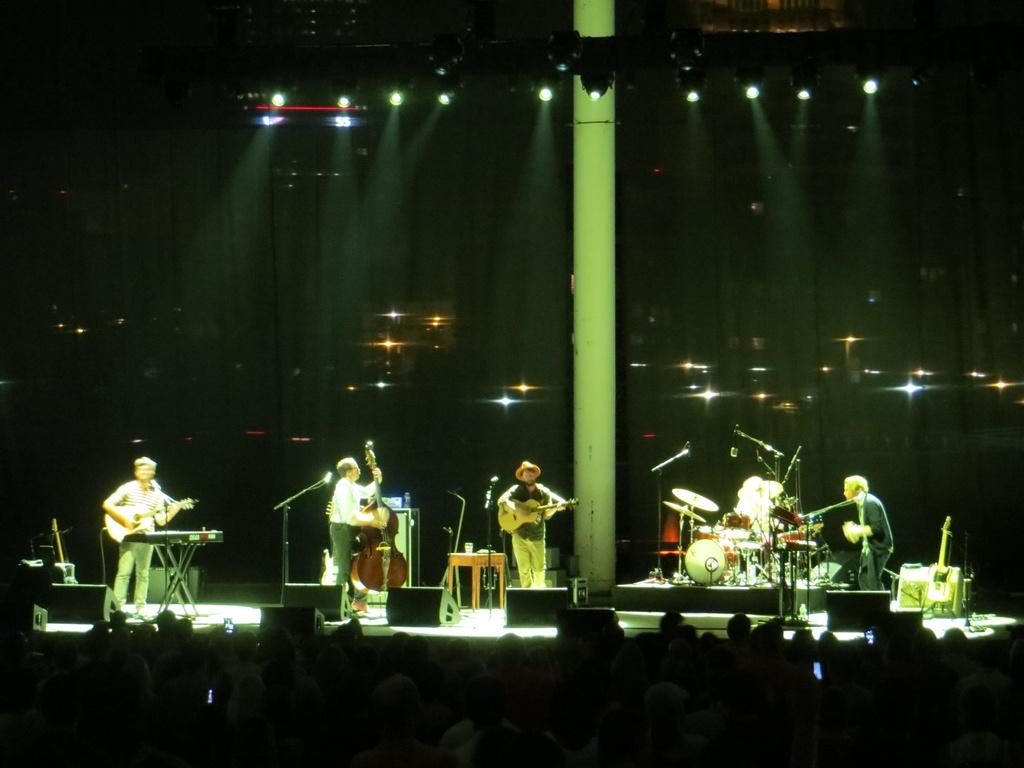What are the persons in the image doing? The persons in the image are playing musical instruments. Who is present in the image besides the musicians? There are audience members in front of the musicians. What type of boats can be seen in the image? There are no boats present in the image; it features musicians playing instruments and an audience. 